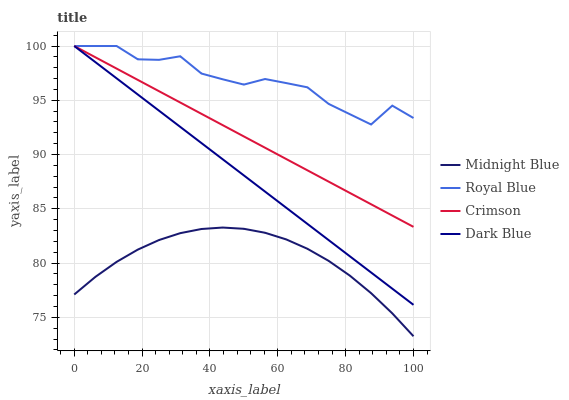Does Royal Blue have the minimum area under the curve?
Answer yes or no. No. Does Midnight Blue have the maximum area under the curve?
Answer yes or no. No. Is Midnight Blue the smoothest?
Answer yes or no. No. Is Midnight Blue the roughest?
Answer yes or no. No. Does Royal Blue have the lowest value?
Answer yes or no. No. Does Midnight Blue have the highest value?
Answer yes or no. No. Is Midnight Blue less than Crimson?
Answer yes or no. Yes. Is Crimson greater than Midnight Blue?
Answer yes or no. Yes. Does Midnight Blue intersect Crimson?
Answer yes or no. No. 